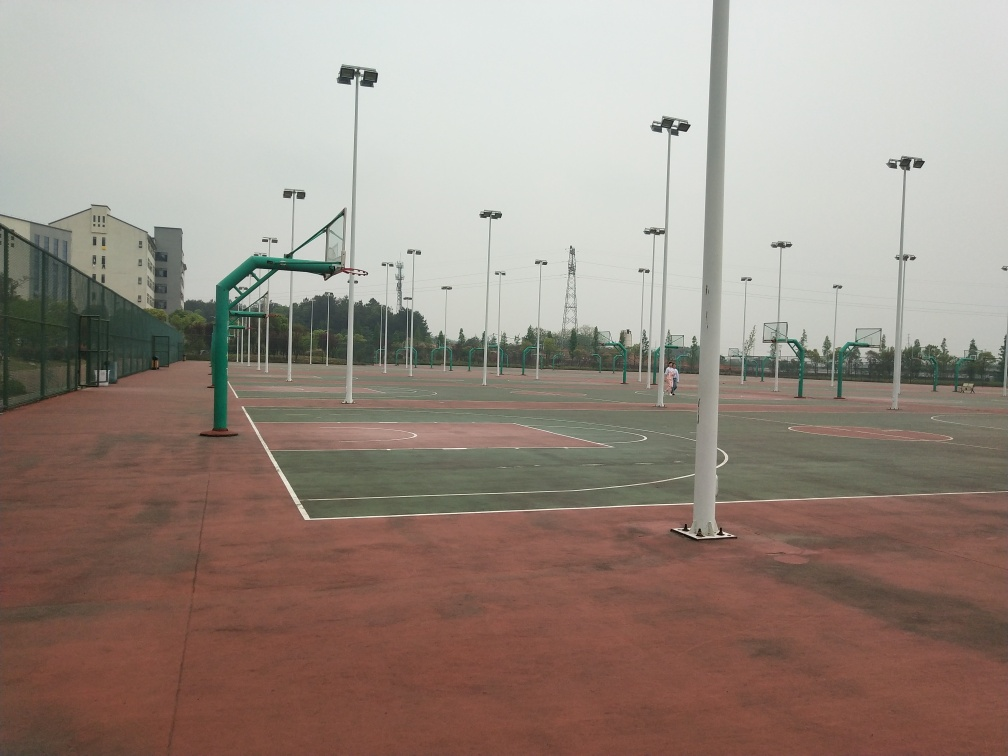Can you tell me more about the type of basketball hoops in this image? Certainly! The basketball hoops in the image feature the standard ring and white backboard. Some hoops are set at the regulation height for official games, while at least one hoop is lower, likely designed for younger players or those learning the game. 